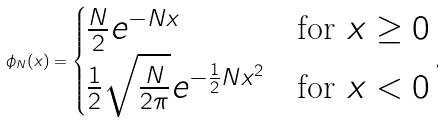Convert formula to latex. <formula><loc_0><loc_0><loc_500><loc_500>\phi _ { N } ( x ) = \begin{cases} \frac { N } { 2 } e ^ { - N x } & \text {for $x\geq 0$} \\ \frac { 1 } { 2 } \sqrt { \frac { N } { 2 \pi } } e ^ { - \frac { 1 } { 2 } N x ^ { 2 } } & \text {for $x<0$} \end{cases} ,</formula> 